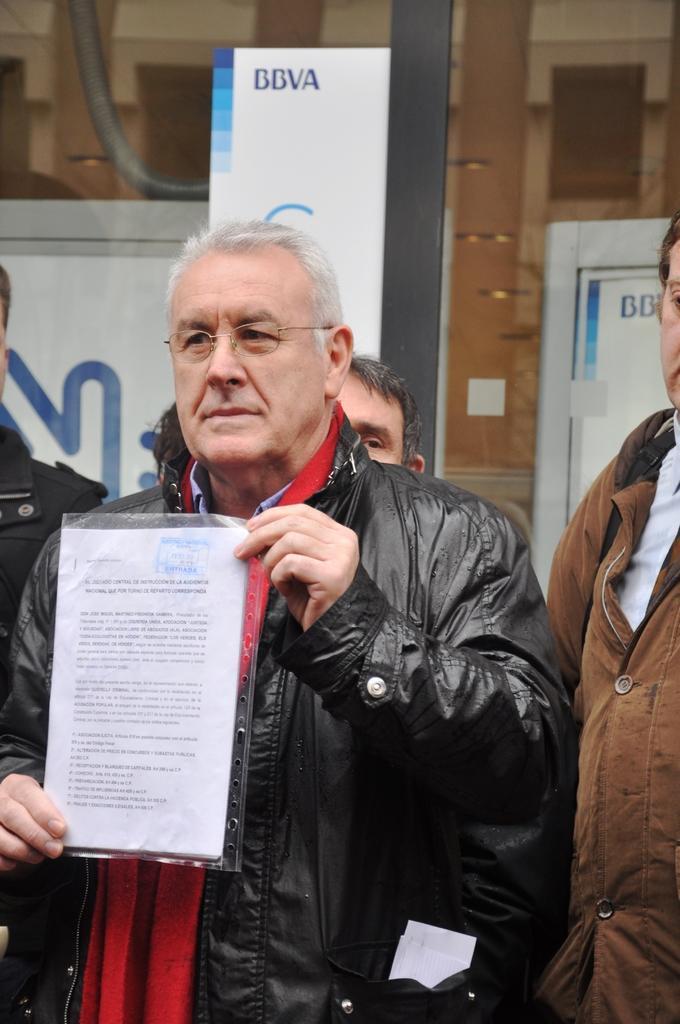In one or two sentences, can you explain what this image depicts? In this picture there is a man who is wearing spectacle, jacket, shirt and holding a paper. Beside him we can see another man. In the background we can see posters, doors and pole. 